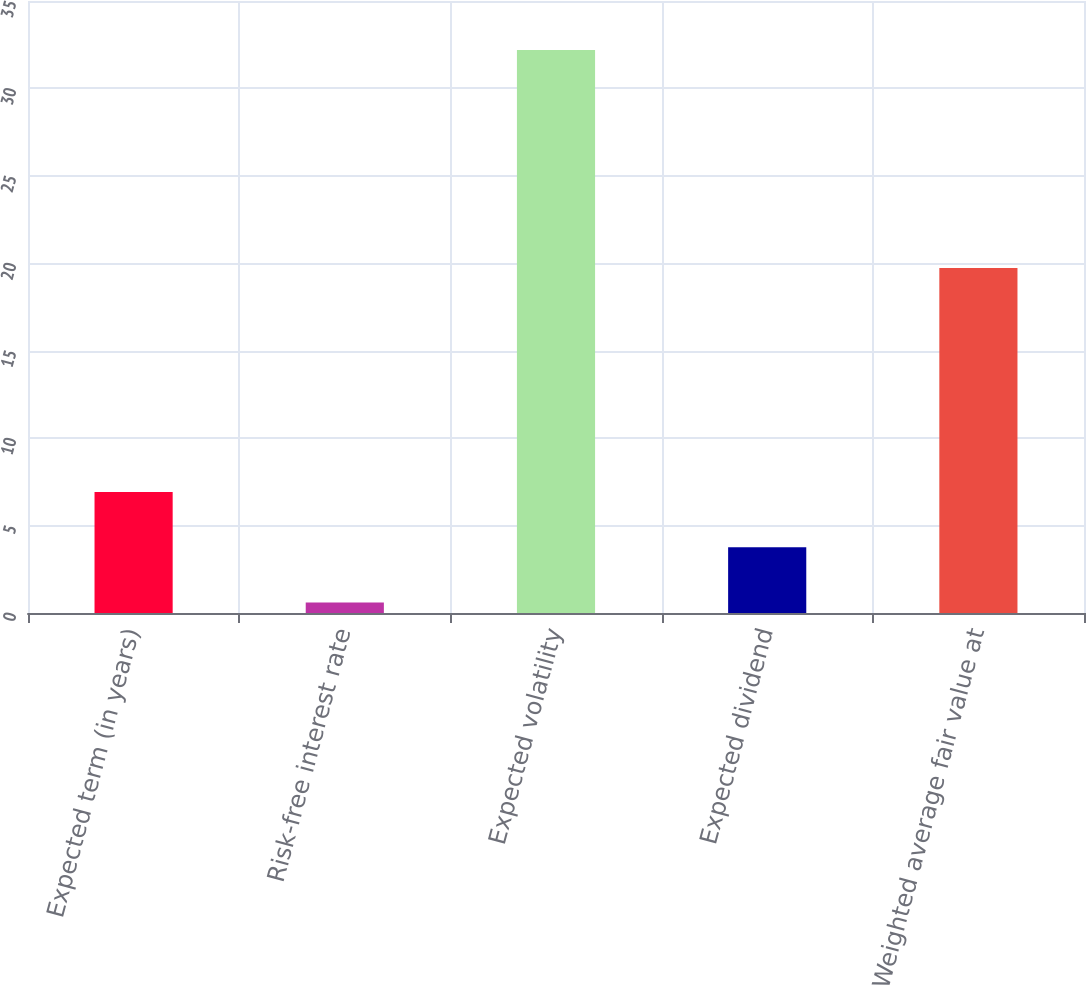Convert chart. <chart><loc_0><loc_0><loc_500><loc_500><bar_chart><fcel>Expected term (in years)<fcel>Risk-free interest rate<fcel>Expected volatility<fcel>Expected dividend<fcel>Weighted average fair value at<nl><fcel>6.92<fcel>0.6<fcel>32.2<fcel>3.76<fcel>19.73<nl></chart> 